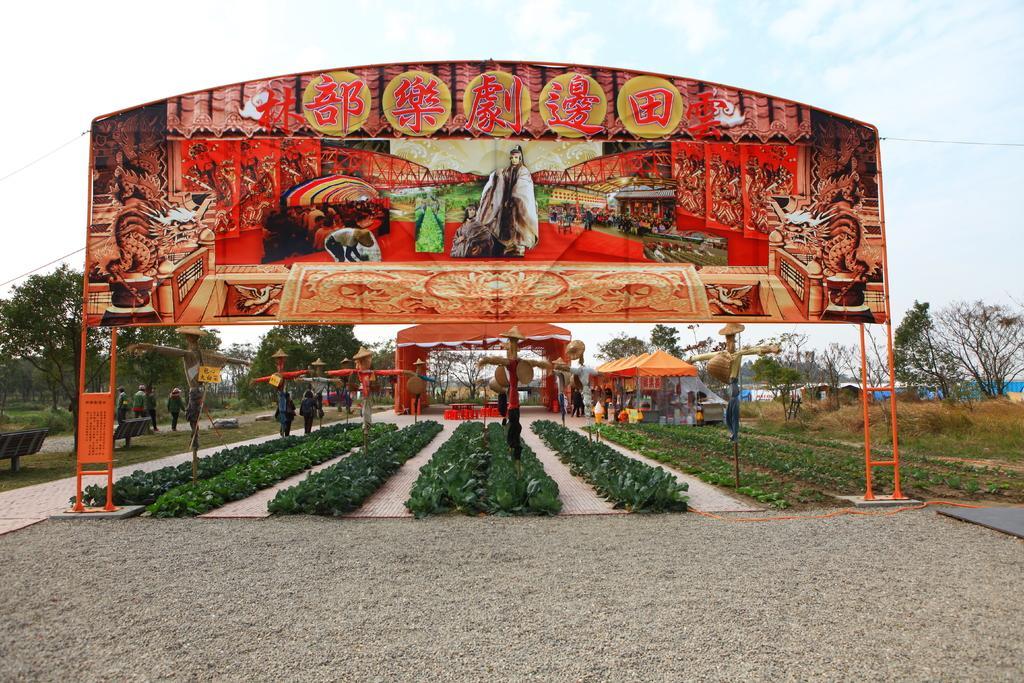Describe this image in one or two sentences. In this picture we can see a poster, benches, plants, tents, scare crows, trees and a group of people on the ground, some objects and in the background we can see the sky with clouds. 